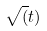<formula> <loc_0><loc_0><loc_500><loc_500>\sqrt { ( } t )</formula> 